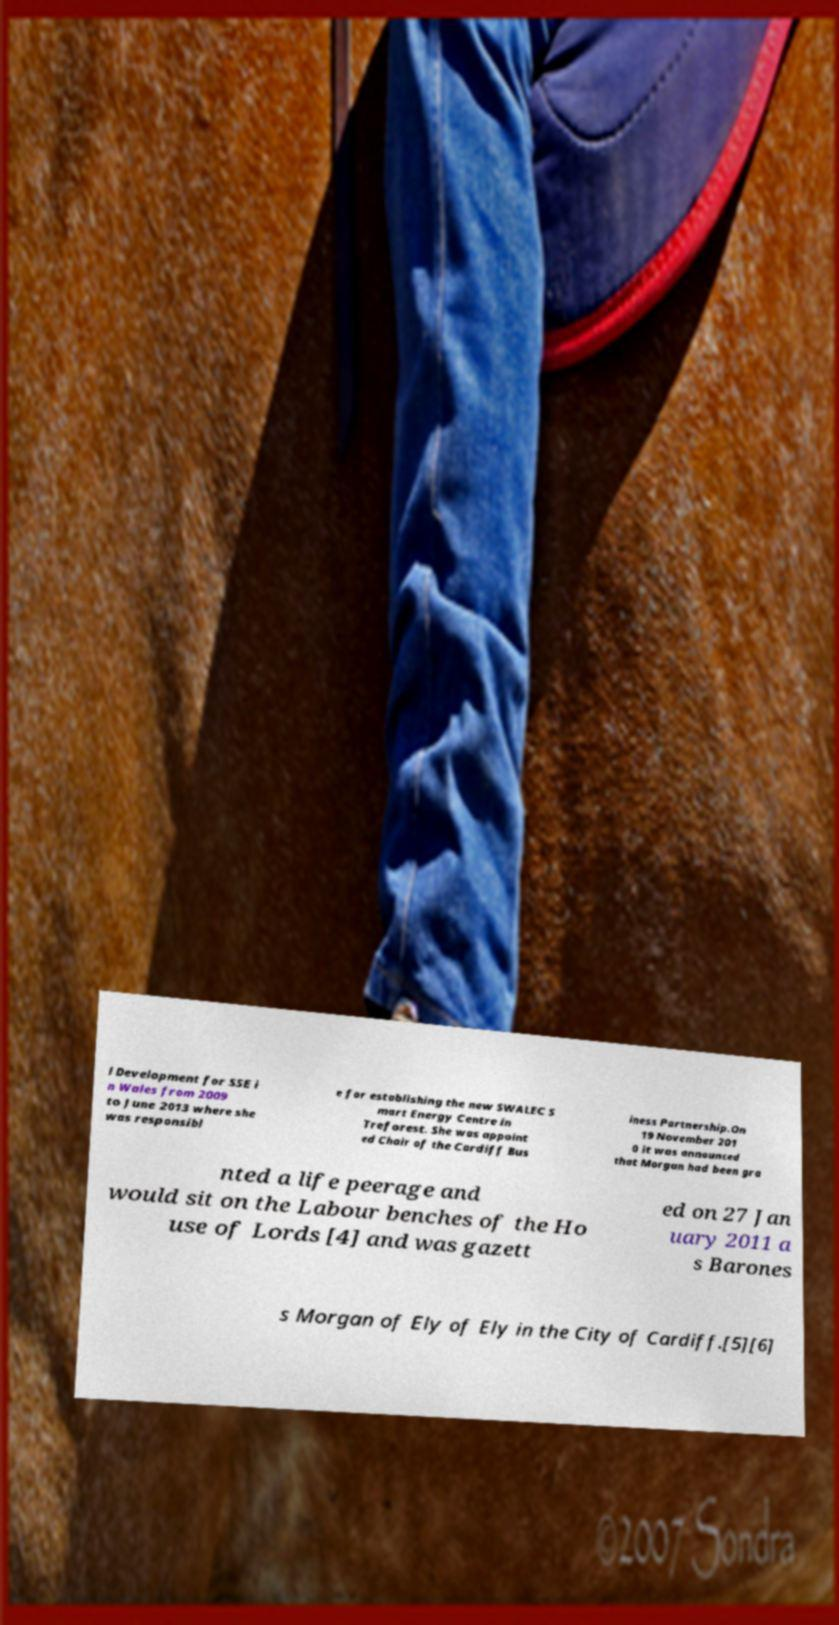Please read and relay the text visible in this image. What does it say? l Development for SSE i n Wales from 2009 to June 2013 where she was responsibl e for establishing the new SWALEC S mart Energy Centre in Treforest. She was appoint ed Chair of the Cardiff Bus iness Partnership.On 19 November 201 0 it was announced that Morgan had been gra nted a life peerage and would sit on the Labour benches of the Ho use of Lords [4] and was gazett ed on 27 Jan uary 2011 a s Barones s Morgan of Ely of Ely in the City of Cardiff.[5][6] 